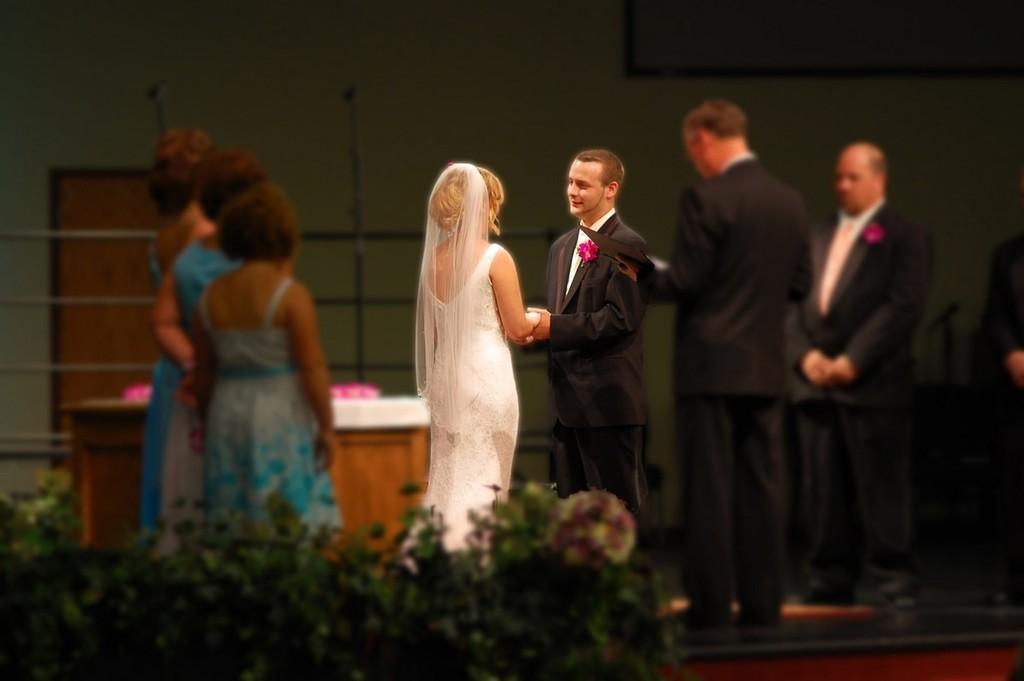In one or two sentences, can you explain what this image depicts? In this picture I can see few people are standing and I can see a man holding a book in his hand and and I can see a man and a woman holding their hands and I can see a table and few plants. 